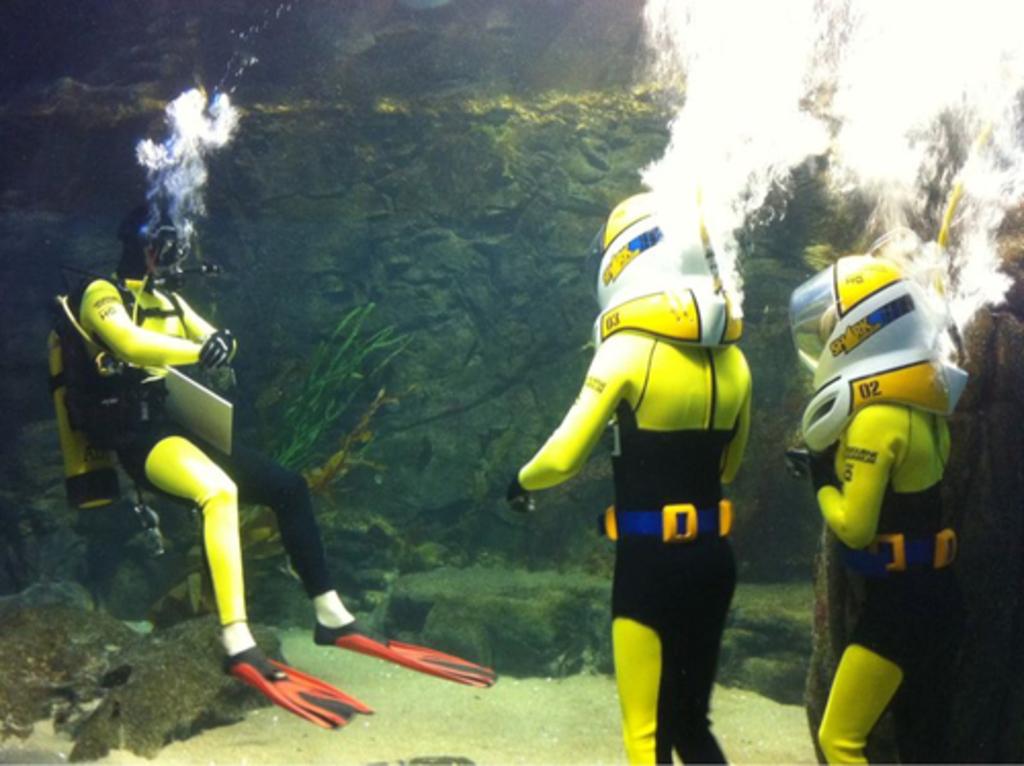What is the number in orange on the right?
Provide a succinct answer. 02. What word is written in yellow on the helmets?
Offer a very short reply. Shark. 